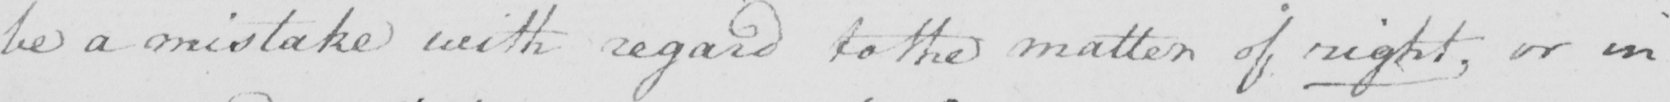Can you tell me what this handwritten text says? be a mistake with regard to the matter of right , or in 